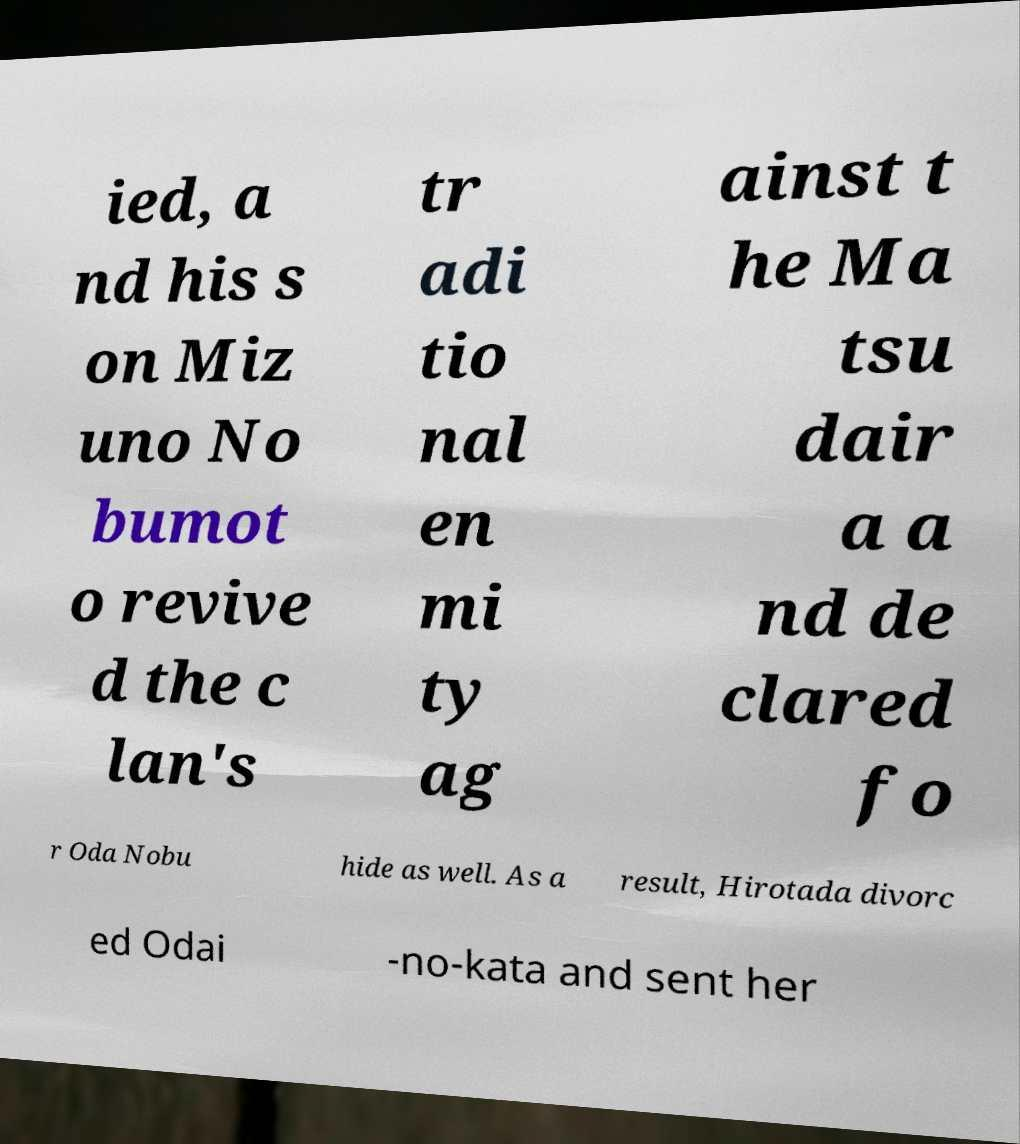Can you accurately transcribe the text from the provided image for me? ied, a nd his s on Miz uno No bumot o revive d the c lan's tr adi tio nal en mi ty ag ainst t he Ma tsu dair a a nd de clared fo r Oda Nobu hide as well. As a result, Hirotada divorc ed Odai -no-kata and sent her 